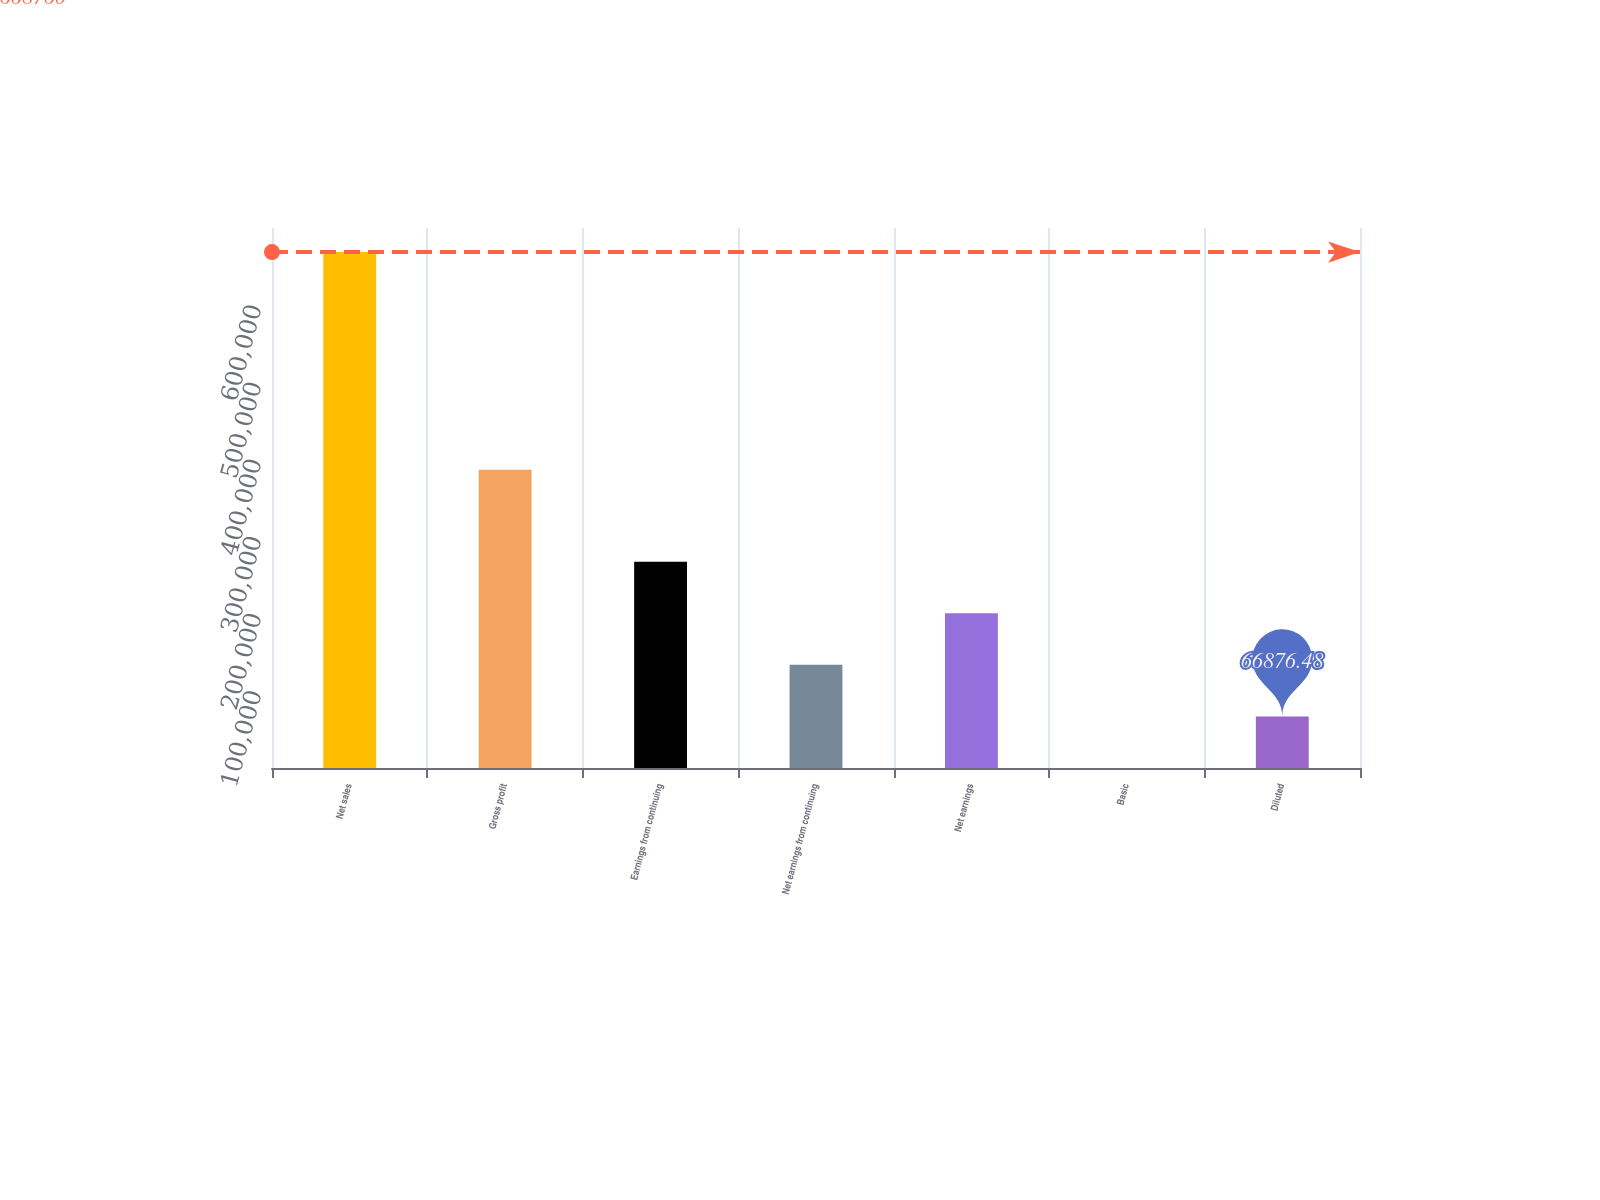Convert chart to OTSL. <chart><loc_0><loc_0><loc_500><loc_500><bar_chart><fcel>Net sales<fcel>Gross profit<fcel>Earnings from continuing<fcel>Net earnings from continuing<fcel>Net earnings<fcel>Basic<fcel>Diluted<nl><fcel>668760<fcel>386752<fcel>267504<fcel>133752<fcel>200628<fcel>0.53<fcel>66876.5<nl></chart> 